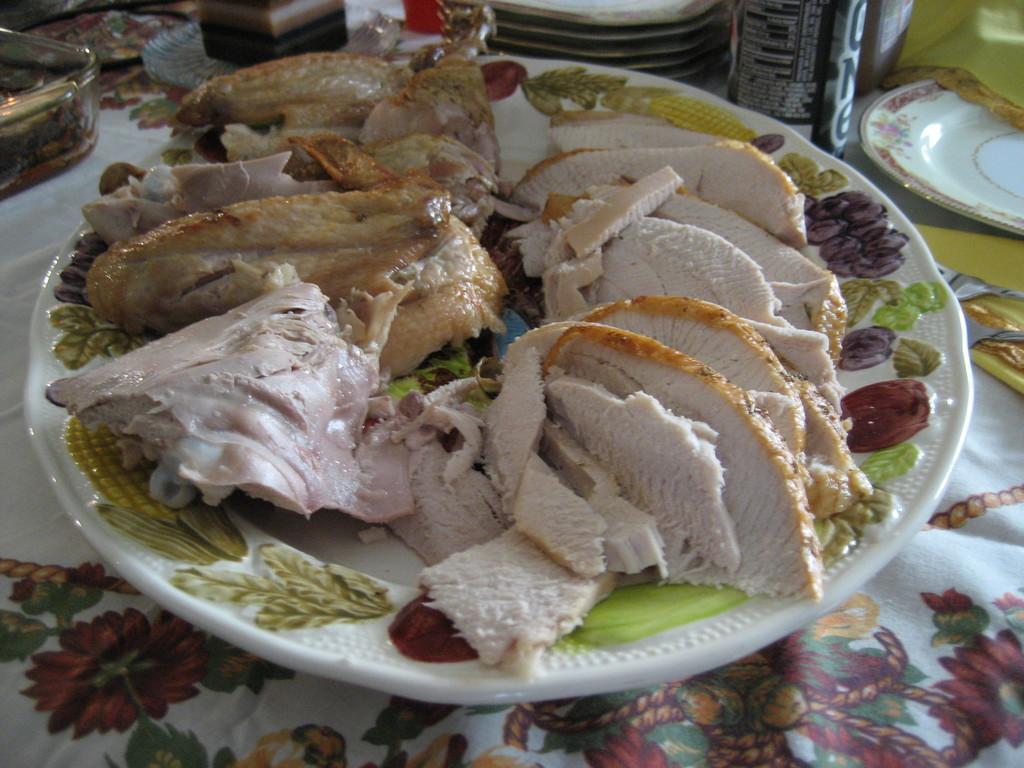In one or two sentences, can you explain what this image depicts? In the picture I can see some food items are placed on the plate which is placed on the table with a tablecloth. In the background, we can see a few more plates and some objects are also placed. 